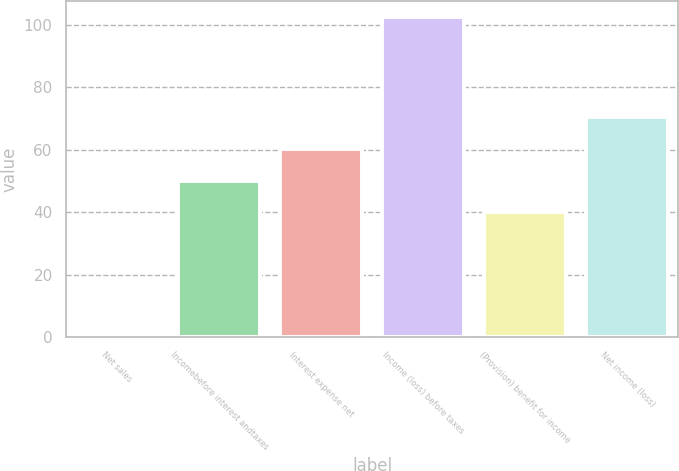Convert chart. <chart><loc_0><loc_0><loc_500><loc_500><bar_chart><fcel>Net sales<fcel>Incomebefore interest andtaxes<fcel>Interest expense net<fcel>Income (loss) before taxes<fcel>(Provision) benefit for income<fcel>Net income (loss)<nl><fcel>0.4<fcel>50.11<fcel>60.32<fcel>102.5<fcel>39.9<fcel>70.53<nl></chart> 